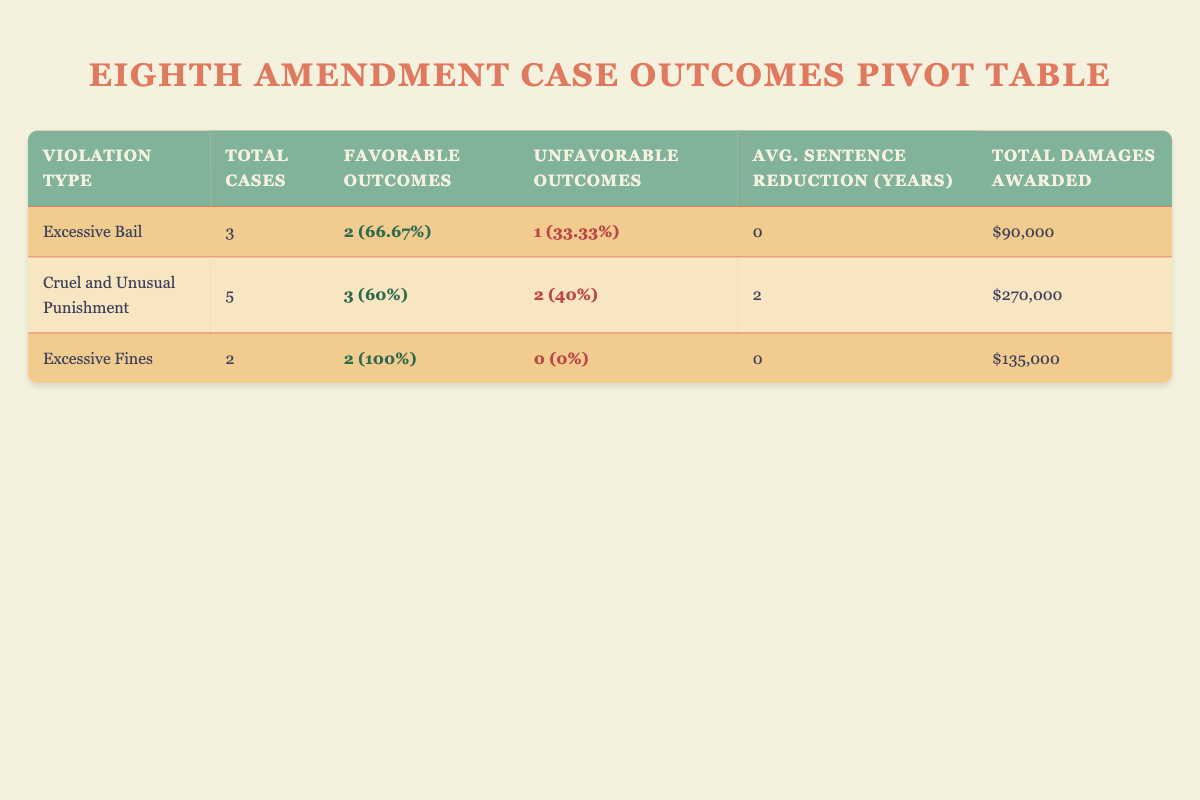What is the total number of cases associated with "Excessive Fines"? From the table, we see that there are 2 cases listed under the "Excessive Fines" violation type (Rodriguez v. Texas and Martinez v. Arizona Department of Corrections).
Answer: 2 How many favorable outcomes were recorded for "Cruel and Unusual Punishment"? In the table, under "Cruel and Unusual Punishment", there are 5 cases, out of which 3 are marked as favorable outcomes.
Answer: 3 What is the total amount of damages awarded for cases classified as "Excessive Bail"? In the "Excessive Bail" section of the table, only two cases (Johnson v. Alabama and Garcia v. New Mexico) resulted in $50,000 and $40,000, respectively. Summing these gives a total of $90,000 for "Excessive Bail".
Answer: $90,000 True or False: There were more unfavorable outcomes than favorable outcomes for "Excessive Bail". Referring to the data for "Excessive Bail", there are 2 favorable outcomes and 1 unfavorable outcome. Since 2 is greater than 1, the statement is false.
Answer: False What is the average sentence reduction for cases with "Cruel and Unusual Punishment"? In the cases of "Cruel and Unusual Punishment", we have two favorable outcomes with sentence reductions of 5 years (Williams v. New York Department of Corrections) and 3 years (Davis v. California), which averages to (5 + 3)/3 = 2 years since there were also 2 unfavorable outcomes with no sentence reduction.
Answer: 2 years How does the total damages awarded for "Excessive Fines" compare with the total damages for "Cruel and Unusual Punishment"? The total damages awarded for "Excessive Fines" is $135,000 (sum of $75,000 and $60,000), while for "Cruel and Unusual Punishment", it is $270,000. Since $135,000 is less than $270,000, we can conclude that damages awarded for "Excessive Fines" are lower than for "Cruel and Unusual Punishment".
Answer: Lower What is the percentage of favorable outcomes to total cases for the "Excessive Bail" violation? The total cases under "Excessive Bail" is 3, with 2 favorable outcomes. To calculate the percentage, we do (2/3)*100 = 66.67%.
Answer: 66.67% 